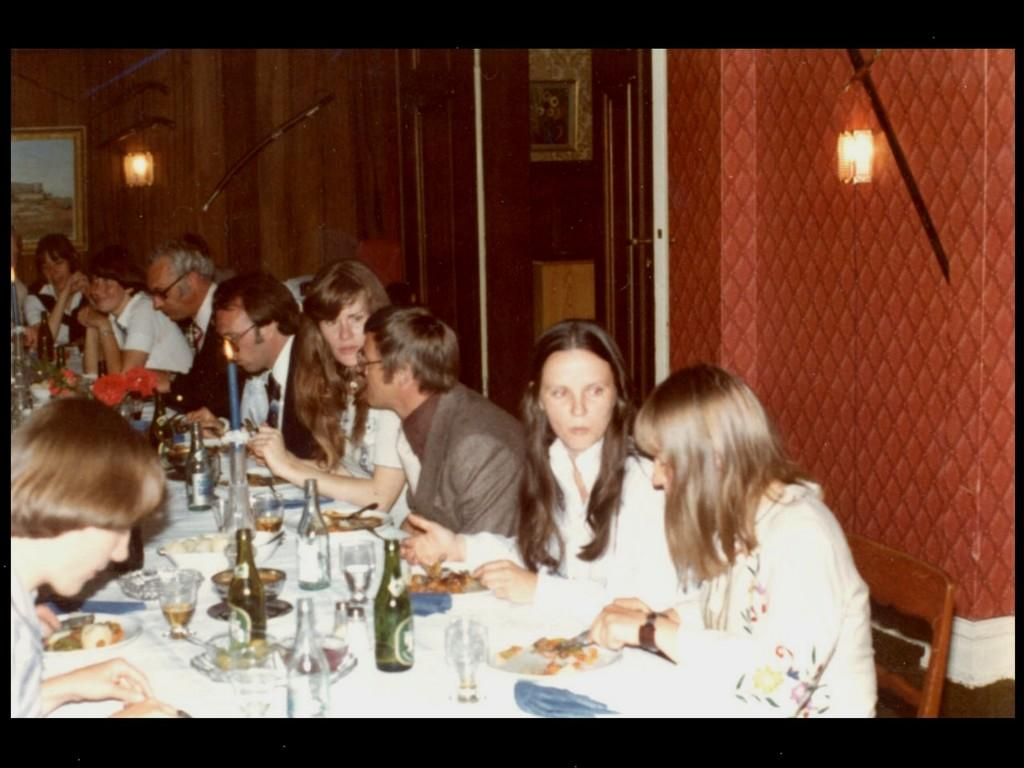What are the people in the image doing? The people in the image are sitting on chairs. What is present on the table in the image? There is a wine bottle and food items on a plate on the table. Can you describe the table in the image? The table is a surface where the wine bottle and food items are placed. What type of pump is being used to inflate the scissors in the image? There is no pump or scissors present in the image. What time of day is depicted in the image? The provided facts do not mention the time of day, so it cannot be determined from the image. 